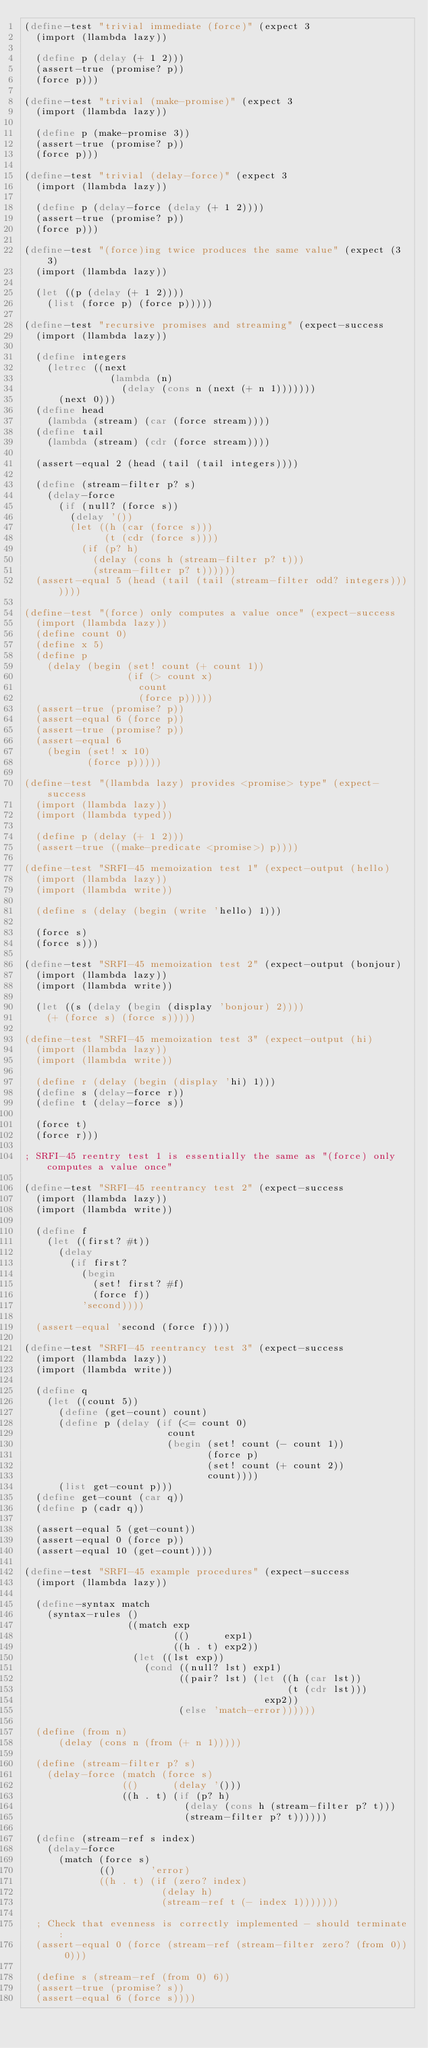Convert code to text. <code><loc_0><loc_0><loc_500><loc_500><_Scheme_>(define-test "trivial immediate (force)" (expect 3
  (import (llambda lazy))

  (define p (delay (+ 1 2)))
  (assert-true (promise? p))
  (force p)))

(define-test "trivial (make-promise)" (expect 3
  (import (llambda lazy))

  (define p (make-promise 3))
  (assert-true (promise? p))
  (force p)))

(define-test "trivial (delay-force)" (expect 3
  (import (llambda lazy))

  (define p (delay-force (delay (+ 1 2))))
  (assert-true (promise? p))
  (force p)))

(define-test "(force)ing twice produces the same value" (expect (3 3)
  (import (llambda lazy))

  (let ((p (delay (+ 1 2))))
    (list (force p) (force p)))))

(define-test "recursive promises and streaming" (expect-success
  (import (llambda lazy))

  (define integers
    (letrec ((next
               (lambda (n)
                 (delay (cons n (next (+ n 1)))))))
      (next 0)))
  (define head
    (lambda (stream) (car (force stream))))
  (define tail
    (lambda (stream) (cdr (force stream))))

  (assert-equal 2 (head (tail (tail integers))))

  (define (stream-filter p? s)
    (delay-force
      (if (null? (force s))
        (delay '())
        (let ((h (car (force s)))
              (t (cdr (force s))))
          (if (p? h)
            (delay (cons h (stream-filter p? t)))
            (stream-filter p? t))))))
  (assert-equal 5 (head (tail (tail (stream-filter odd? integers)))))))

(define-test "(force) only computes a value once" (expect-success
  (import (llambda lazy))
  (define count 0)
  (define x 5)
  (define p
    (delay (begin (set! count (+ count 1))
                  (if (> count x)
                    count
                    (force p)))))
  (assert-true (promise? p))
  (assert-equal 6 (force p))
  (assert-true (promise? p))
  (assert-equal 6
    (begin (set! x 10)
           (force p)))))

(define-test "(llambda lazy) provides <promise> type" (expect-success
  (import (llambda lazy))
  (import (llambda typed))

  (define p (delay (+ 1 2)))
  (assert-true ((make-predicate <promise>) p))))

(define-test "SRFI-45 memoization test 1" (expect-output (hello)
  (import (llambda lazy))
  (import (llambda write))

  (define s (delay (begin (write 'hello) 1)))

  (force s)
  (force s)))

(define-test "SRFI-45 memoization test 2" (expect-output (bonjour)
  (import (llambda lazy))
  (import (llambda write))

  (let ((s (delay (begin (display 'bonjour) 2))))
    (+ (force s) (force s)))))

(define-test "SRFI-45 memoization test 3" (expect-output (hi)
  (import (llambda lazy))
  (import (llambda write))

  (define r (delay (begin (display 'hi) 1)))
  (define s (delay-force r))
  (define t (delay-force s))

  (force t)
  (force r)))

; SRFI-45 reentry test 1 is essentially the same as "(force) only computes a value once"

(define-test "SRFI-45 reentrancy test 2" (expect-success
  (import (llambda lazy))
  (import (llambda write))

  (define f
    (let ((first? #t))
      (delay
        (if first?
          (begin
            (set! first? #f)
            (force f))
          'second))))

  (assert-equal 'second (force f))))

(define-test "SRFI-45 reentrancy test 3" (expect-success
  (import (llambda lazy))
  (import (llambda write))

  (define q
    (let ((count 5))
      (define (get-count) count)
      (define p (delay (if (<= count 0)
                         count
                         (begin (set! count (- count 1))
                                (force p)
                                (set! count (+ count 2))
                                count))))
      (list get-count p)))
  (define get-count (car q))
  (define p (cadr q))

  (assert-equal 5 (get-count))
  (assert-equal 0 (force p))
  (assert-equal 10 (get-count))))

(define-test "SRFI-45 example procedures" (expect-success
  (import (llambda lazy))

  (define-syntax match
    (syntax-rules ()
                  ((match exp
                          (()      exp1)
                          ((h . t) exp2))
                   (let ((lst exp))
                     (cond ((null? lst) exp1)
                           ((pair? lst) (let ((h (car lst))
                                              (t (cdr lst)))
                                          exp2))
                           (else 'match-error))))))

  (define (from n)
      (delay (cons n (from (+ n 1)))))

  (define (stream-filter p? s)
    (delay-force (match (force s)
                 (()      (delay '()))
                 ((h . t) (if (p? h)
                            (delay (cons h (stream-filter p? t)))
                            (stream-filter p? t))))))

  (define (stream-ref s index)
    (delay-force
      (match (force s)
             (()      'error)
             ((h . t) (if (zero? index)
                        (delay h)
                        (stream-ref t (- index 1)))))))

  ; Check that evenness is correctly implemented - should terminate:
  (assert-equal 0 (force (stream-ref (stream-filter zero? (from 0)) 0)))

  (define s (stream-ref (from 0) 6))
  (assert-true (promise? s))
  (assert-equal 6 (force s))))
</code> 